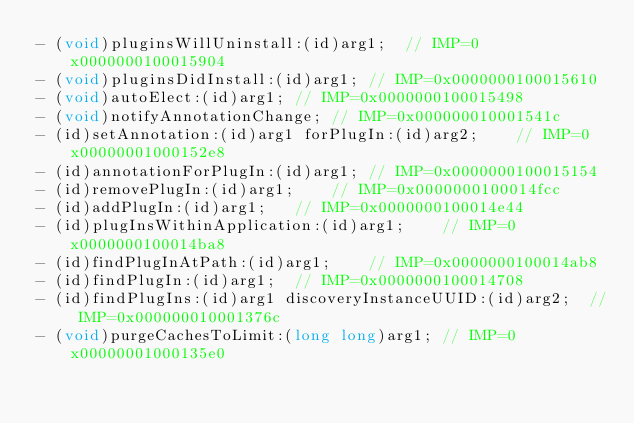<code> <loc_0><loc_0><loc_500><loc_500><_C_>- (void)pluginsWillUninstall:(id)arg1;	// IMP=0x0000000100015904
- (void)pluginsDidInstall:(id)arg1;	// IMP=0x0000000100015610
- (void)autoElect:(id)arg1;	// IMP=0x0000000100015498
- (void)notifyAnnotationChange;	// IMP=0x000000010001541c
- (id)setAnnotation:(id)arg1 forPlugIn:(id)arg2;	// IMP=0x00000001000152e8
- (id)annotationForPlugIn:(id)arg1;	// IMP=0x0000000100015154
- (id)removePlugIn:(id)arg1;	// IMP=0x0000000100014fcc
- (id)addPlugIn:(id)arg1;	// IMP=0x0000000100014e44
- (id)plugInsWithinApplication:(id)arg1;	// IMP=0x0000000100014ba8
- (id)findPlugInAtPath:(id)arg1;	// IMP=0x0000000100014ab8
- (id)findPlugIn:(id)arg1;	// IMP=0x0000000100014708
- (id)findPlugIns:(id)arg1 discoveryInstanceUUID:(id)arg2;	// IMP=0x000000010001376c
- (void)purgeCachesToLimit:(long long)arg1;	// IMP=0x00000001000135e0</code> 